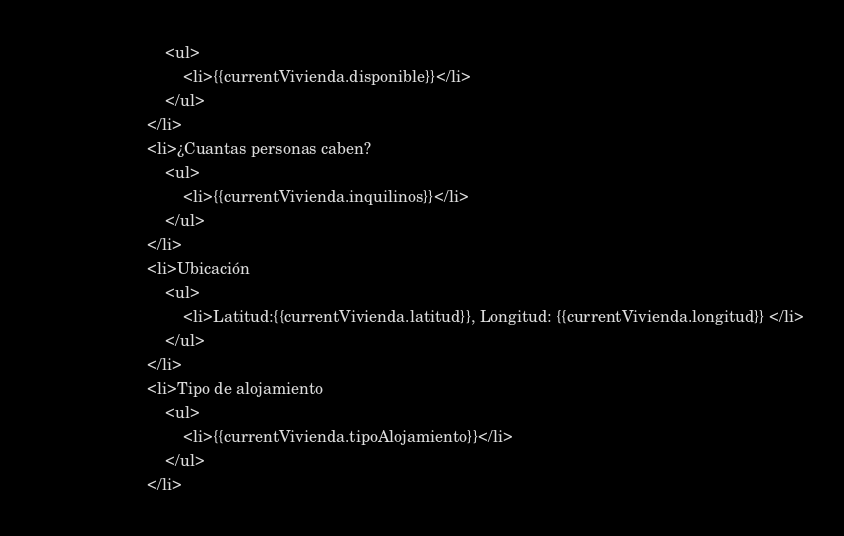<code> <loc_0><loc_0><loc_500><loc_500><_HTML_>                            <ul>
                                <li>{{currentVivienda.disponible}}</li>
                            </ul>
                        </li>
                        <li>¿Cuantas personas caben?
                            <ul>
                                <li>{{currentVivienda.inquilinos}}</li>
                            </ul>
                        </li>
                        <li>Ubicación 
                            <ul>
                                <li>Latitud:{{currentVivienda.latitud}}, Longitud: {{currentVivienda.longitud}} </li>
                            </ul>
                        </li>
                        <li>Tipo de alojamiento
                            <ul>
                                <li>{{currentVivienda.tipoAlojamiento}}</li>
                            </ul>
                        </li></code> 